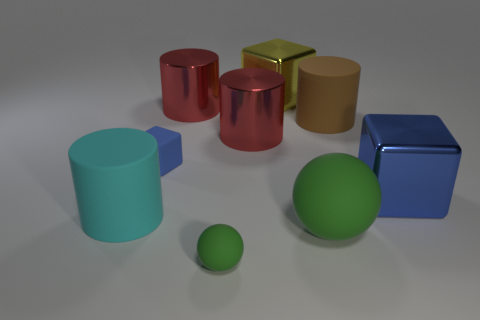There is a blue metal cube; is its size the same as the cylinder that is in front of the matte cube? yes 